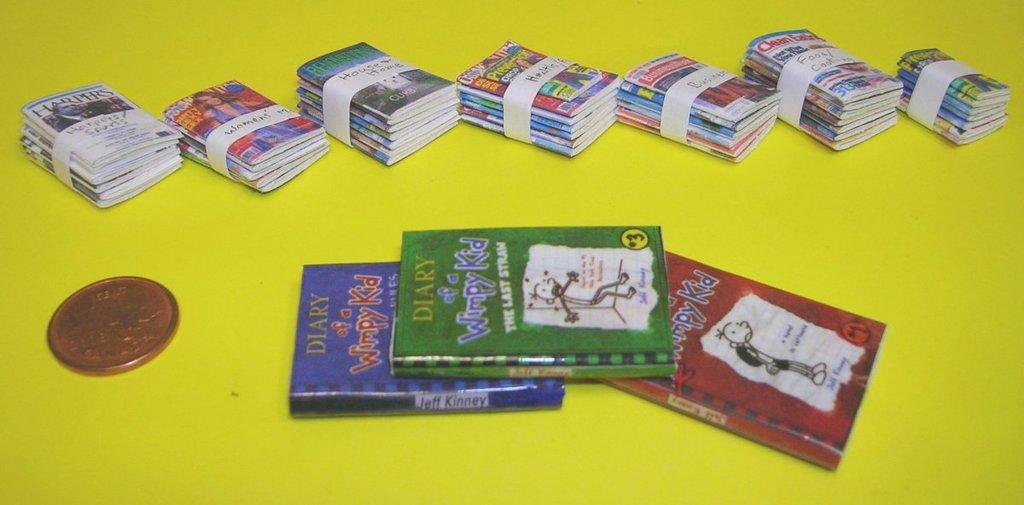<image>
Provide a brief description of the given image. a book called The Diary of a Wimpy Kid 